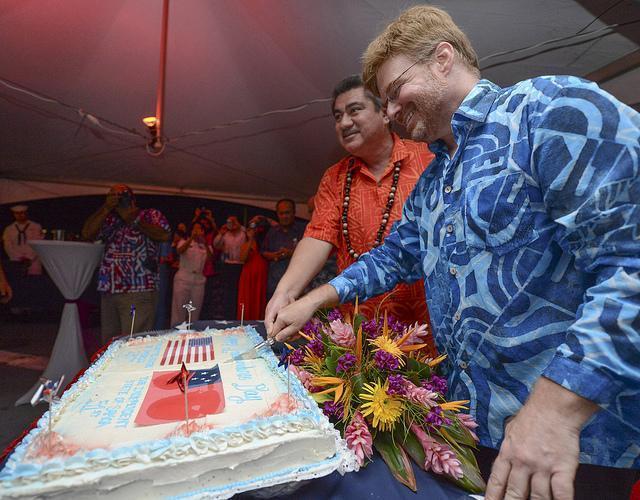How many people are there?
Give a very brief answer. 7. 